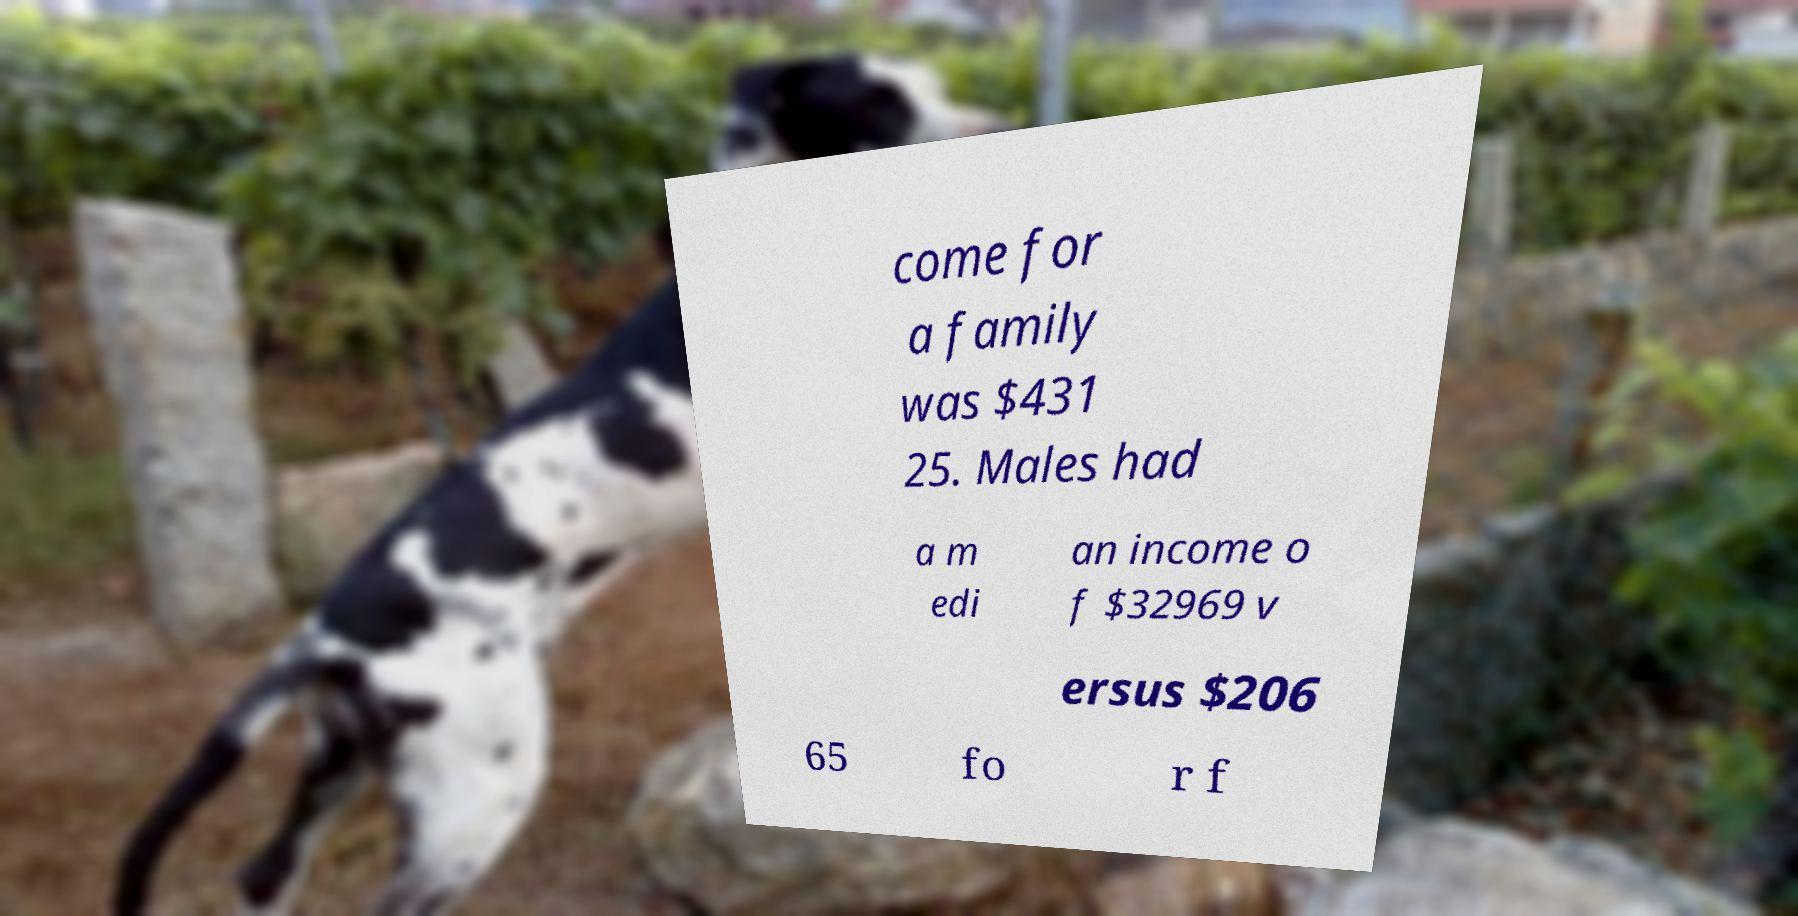Please read and relay the text visible in this image. What does it say? come for a family was $431 25. Males had a m edi an income o f $32969 v ersus $206 65 fo r f 